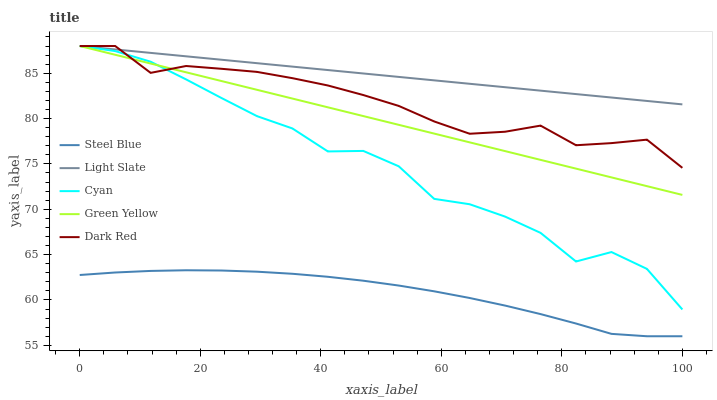Does Steel Blue have the minimum area under the curve?
Answer yes or no. Yes. Does Light Slate have the maximum area under the curve?
Answer yes or no. Yes. Does Cyan have the minimum area under the curve?
Answer yes or no. No. Does Cyan have the maximum area under the curve?
Answer yes or no. No. Is Green Yellow the smoothest?
Answer yes or no. Yes. Is Cyan the roughest?
Answer yes or no. Yes. Is Cyan the smoothest?
Answer yes or no. No. Is Green Yellow the roughest?
Answer yes or no. No. Does Steel Blue have the lowest value?
Answer yes or no. Yes. Does Cyan have the lowest value?
Answer yes or no. No. Does Dark Red have the highest value?
Answer yes or no. Yes. Does Steel Blue have the highest value?
Answer yes or no. No. Is Steel Blue less than Light Slate?
Answer yes or no. Yes. Is Dark Red greater than Steel Blue?
Answer yes or no. Yes. Does Light Slate intersect Green Yellow?
Answer yes or no. Yes. Is Light Slate less than Green Yellow?
Answer yes or no. No. Is Light Slate greater than Green Yellow?
Answer yes or no. No. Does Steel Blue intersect Light Slate?
Answer yes or no. No. 